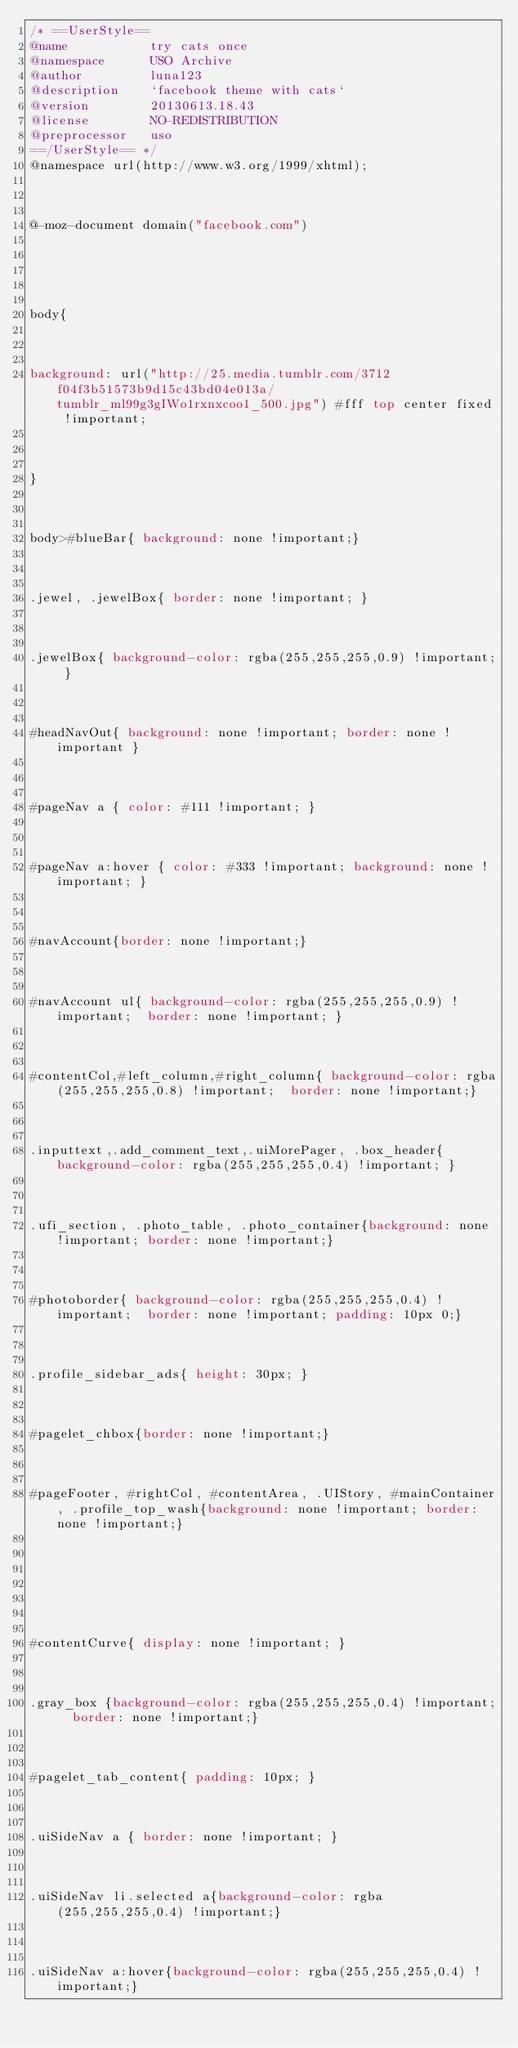Convert code to text. <code><loc_0><loc_0><loc_500><loc_500><_CSS_>/* ==UserStyle==
@name           try cats once
@namespace      USO Archive
@author         luna123
@description    `facebook theme with cats`
@version        20130613.18.43
@license        NO-REDISTRIBUTION
@preprocessor   uso
==/UserStyle== */
@namespace url(http://www.w3.org/1999/xhtml);



@-moz-document domain("facebook.com") 





body{



background: url("http://25.media.tumblr.com/3712f04f3b51573b9d15c43bd04e013a/tumblr_ml99g3gIWo1rxnxcoo1_500.jpg") #fff top center fixed !important;



}



body>#blueBar{ background: none !important;}



.jewel, .jewelBox{ border: none !important; }



.jewelBox{ background-color: rgba(255,255,255,0.9) !important; }



#headNavOut{ background: none !important; border: none !important }



#pageNav a { color: #111 !important; }



#pageNav a:hover { color: #333 !important; background: none !important; }



#navAccount{border: none !important;}



#navAccount ul{ background-color: rgba(255,255,255,0.9) !important;  border: none !important; }



#contentCol,#left_column,#right_column{ background-color: rgba(255,255,255,0.8) !important;  border: none !important;}



.inputtext,.add_comment_text,.uiMorePager, .box_header{ background-color: rgba(255,255,255,0.4) !important; }



.ufi_section, .photo_table, .photo_container{background: none !important; border: none !important;}



#photoborder{ background-color: rgba(255,255,255,0.4) !important;  border: none !important; padding: 10px 0;}



.profile_sidebar_ads{ height: 30px; }



#pagelet_chbox{border: none !important;}



#pageFooter, #rightCol, #contentArea, .UIStory, #mainContainer, .profile_top_wash{background: none !important; border: none !important;}







#contentCurve{ display: none !important; }



.gray_box {background-color: rgba(255,255,255,0.4) !important;  border: none !important;}



#pagelet_tab_content{ padding: 10px; }



.uiSideNav a { border: none !important; }



.uiSideNav li.selected a{background-color: rgba(255,255,255,0.4) !important;}



.uiSideNav a:hover{background-color: rgba(255,255,255,0.4) !important;}</code> 